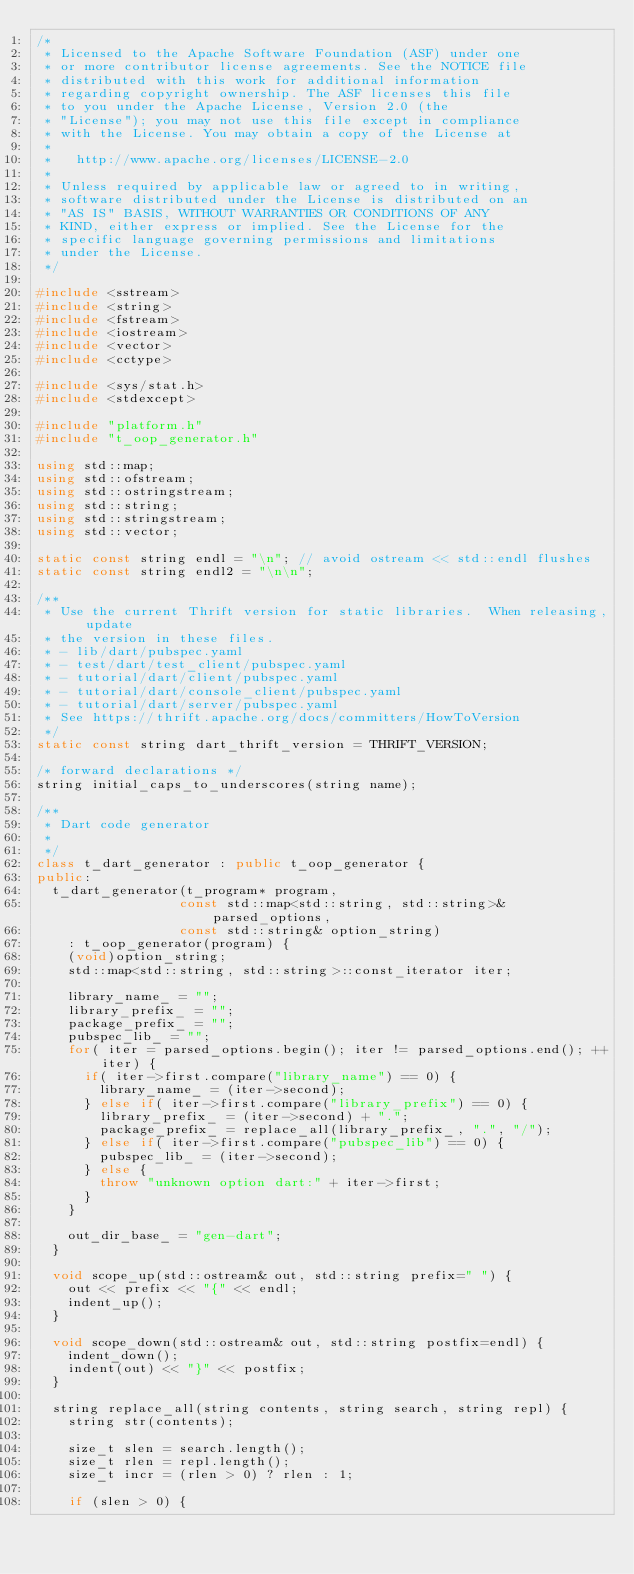Convert code to text. <code><loc_0><loc_0><loc_500><loc_500><_C++_>/*
 * Licensed to the Apache Software Foundation (ASF) under one
 * or more contributor license agreements. See the NOTICE file
 * distributed with this work for additional information
 * regarding copyright ownership. The ASF licenses this file
 * to you under the Apache License, Version 2.0 (the
 * "License"); you may not use this file except in compliance
 * with the License. You may obtain a copy of the License at
 *
 *   http://www.apache.org/licenses/LICENSE-2.0
 *
 * Unless required by applicable law or agreed to in writing,
 * software distributed under the License is distributed on an
 * "AS IS" BASIS, WITHOUT WARRANTIES OR CONDITIONS OF ANY
 * KIND, either express or implied. See the License for the
 * specific language governing permissions and limitations
 * under the License.
 */

#include <sstream>
#include <string>
#include <fstream>
#include <iostream>
#include <vector>
#include <cctype>

#include <sys/stat.h>
#include <stdexcept>

#include "platform.h"
#include "t_oop_generator.h"

using std::map;
using std::ofstream;
using std::ostringstream;
using std::string;
using std::stringstream;
using std::vector;

static const string endl = "\n"; // avoid ostream << std::endl flushes
static const string endl2 = "\n\n";

/**
 * Use the current Thrift version for static libraries.  When releasing, update
 * the version in these files.
 * - lib/dart/pubspec.yaml
 * - test/dart/test_client/pubspec.yaml
 * - tutorial/dart/client/pubspec.yaml
 * - tutorial/dart/console_client/pubspec.yaml
 * - tutorial/dart/server/pubspec.yaml
 * See https://thrift.apache.org/docs/committers/HowToVersion
 */
static const string dart_thrift_version = THRIFT_VERSION;

/* forward declarations */
string initial_caps_to_underscores(string name);

/**
 * Dart code generator
 *
 */
class t_dart_generator : public t_oop_generator {
public:
  t_dart_generator(t_program* program,
                  const std::map<std::string, std::string>& parsed_options,
                  const std::string& option_string)
    : t_oop_generator(program) {
    (void)option_string;
    std::map<std::string, std::string>::const_iterator iter;

    library_name_ = "";
    library_prefix_ = "";
    package_prefix_ = "";
    pubspec_lib_ = "";
    for( iter = parsed_options.begin(); iter != parsed_options.end(); ++iter) {
      if( iter->first.compare("library_name") == 0) {
        library_name_ = (iter->second);
      } else if( iter->first.compare("library_prefix") == 0) {
        library_prefix_ = (iter->second) + ".";
        package_prefix_ = replace_all(library_prefix_, ".", "/");
      } else if( iter->first.compare("pubspec_lib") == 0) {
        pubspec_lib_ = (iter->second);
      } else {
        throw "unknown option dart:" + iter->first; 
      }
    }

    out_dir_base_ = "gen-dart";
  }

  void scope_up(std::ostream& out, std::string prefix=" ") {
    out << prefix << "{" << endl;
    indent_up();
  }

  void scope_down(std::ostream& out, std::string postfix=endl) {
    indent_down();
    indent(out) << "}" << postfix;
  }

  string replace_all(string contents, string search, string repl) {
    string str(contents);

    size_t slen = search.length();
    size_t rlen = repl.length();
    size_t incr = (rlen > 0) ? rlen : 1;

    if (slen > 0) {</code> 